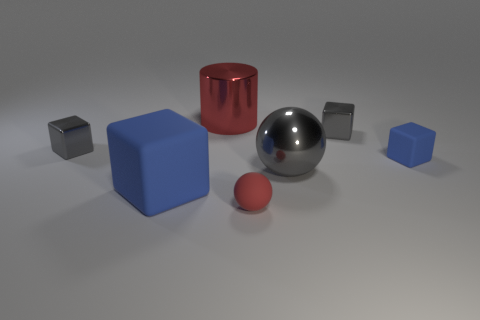Are there any other things that have the same shape as the red shiny object?
Offer a very short reply. No. What is the shape of the big thing on the right side of the tiny red rubber object?
Give a very brief answer. Sphere. There is a small shiny object that is on the right side of the large object in front of the big object to the right of the shiny cylinder; what is its shape?
Your answer should be compact. Cube. How many things are either tiny red spheres or small gray cubes?
Provide a succinct answer. 3. There is a gray thing right of the large gray sphere; does it have the same shape as the tiny rubber object in front of the large sphere?
Provide a succinct answer. No. How many big things are to the left of the gray metal ball and in front of the small blue cube?
Your answer should be very brief. 1. What number of other objects are the same size as the matte sphere?
Give a very brief answer. 3. What is the large thing that is both on the left side of the red rubber object and in front of the large cylinder made of?
Keep it short and to the point. Rubber. There is a tiny rubber ball; does it have the same color as the big metallic thing that is left of the big gray shiny sphere?
Provide a succinct answer. Yes. There is another blue object that is the same shape as the big blue rubber thing; what size is it?
Keep it short and to the point. Small. 